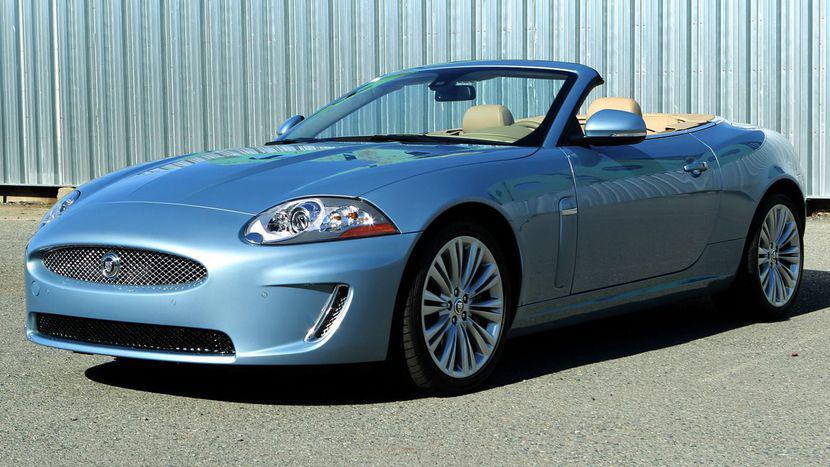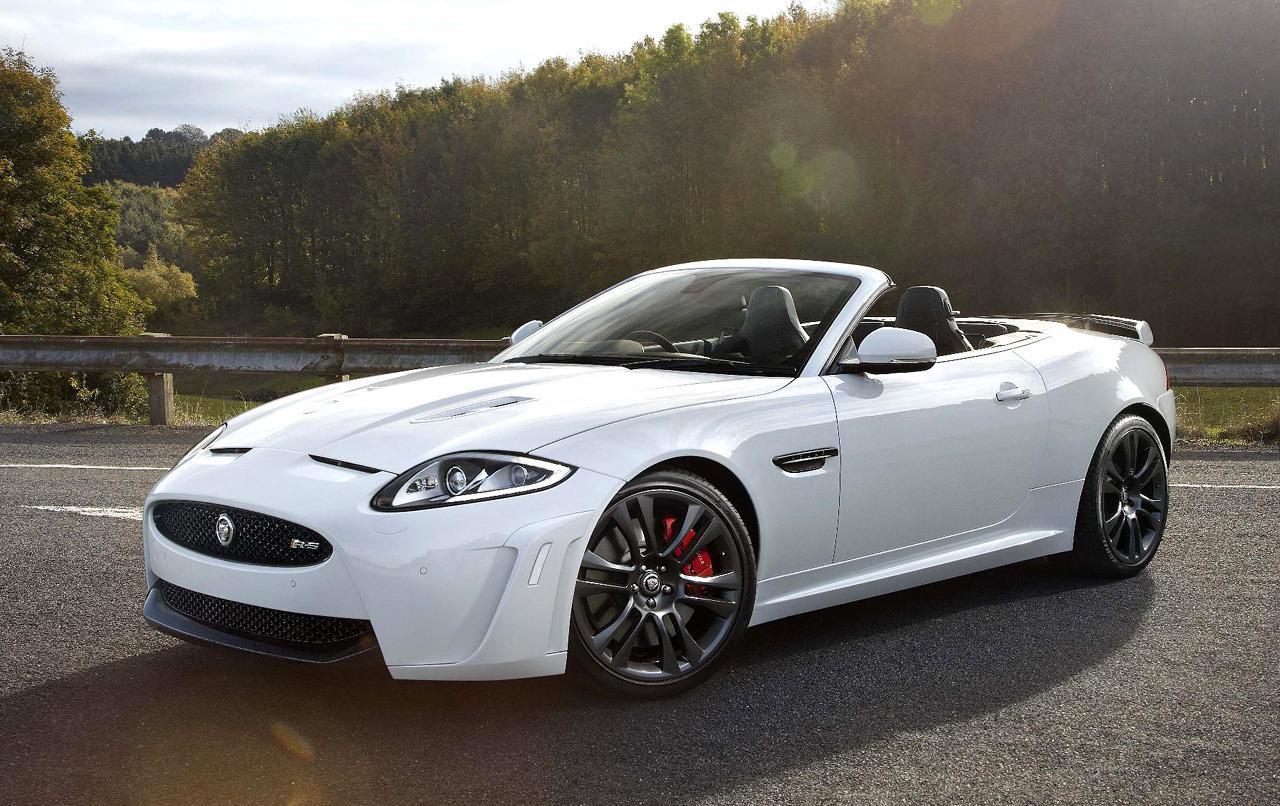The first image is the image on the left, the second image is the image on the right. Given the left and right images, does the statement "There is a black convertible on a paved street with its top down" hold true? Answer yes or no. No. 